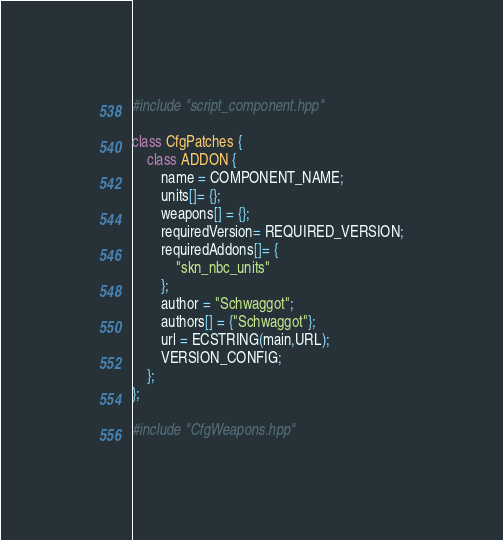<code> <loc_0><loc_0><loc_500><loc_500><_C++_>#include "script_component.hpp"

class CfgPatches {
    class ADDON {
        name = COMPONENT_NAME;
        units[]= {};
        weapons[] = {};
        requiredVersion= REQUIRED_VERSION;
        requiredAddons[]= {
            "skn_nbc_units"
        };
        author = "Schwaggot";
        authors[] = {"Schwaggot"};
        url = ECSTRING(main,URL);
        VERSION_CONFIG;
    };
};

#include "CfgWeapons.hpp"
</code> 